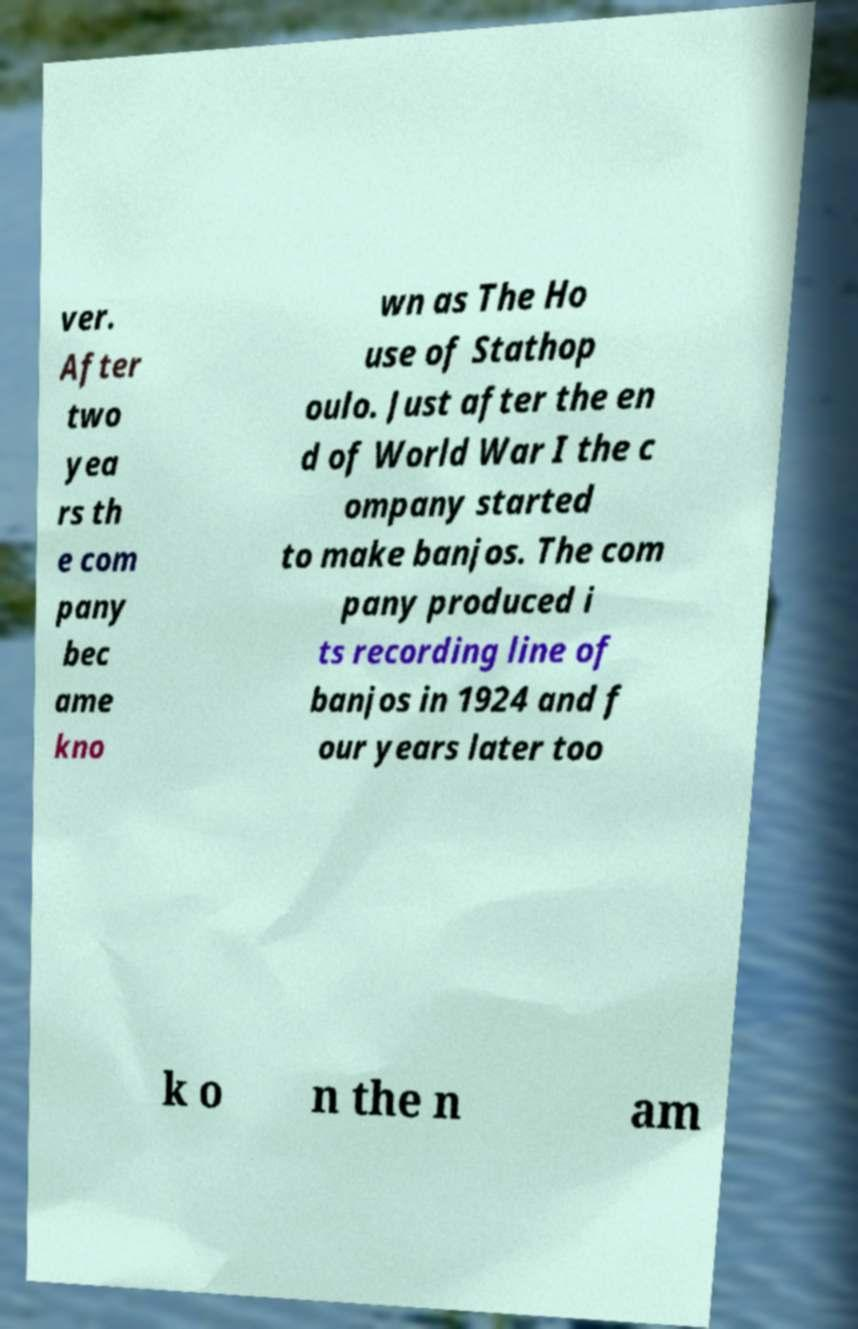I need the written content from this picture converted into text. Can you do that? ver. After two yea rs th e com pany bec ame kno wn as The Ho use of Stathop oulo. Just after the en d of World War I the c ompany started to make banjos. The com pany produced i ts recording line of banjos in 1924 and f our years later too k o n the n am 